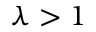<formula> <loc_0><loc_0><loc_500><loc_500>\lambda > 1</formula> 